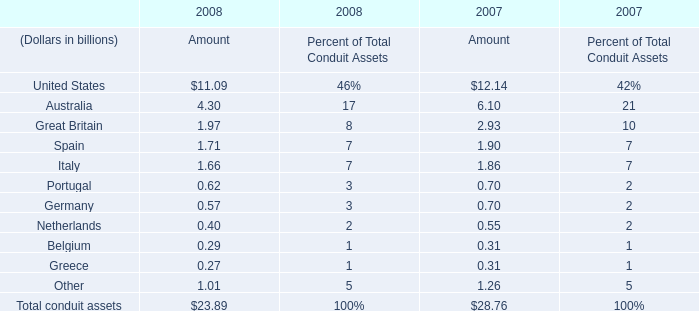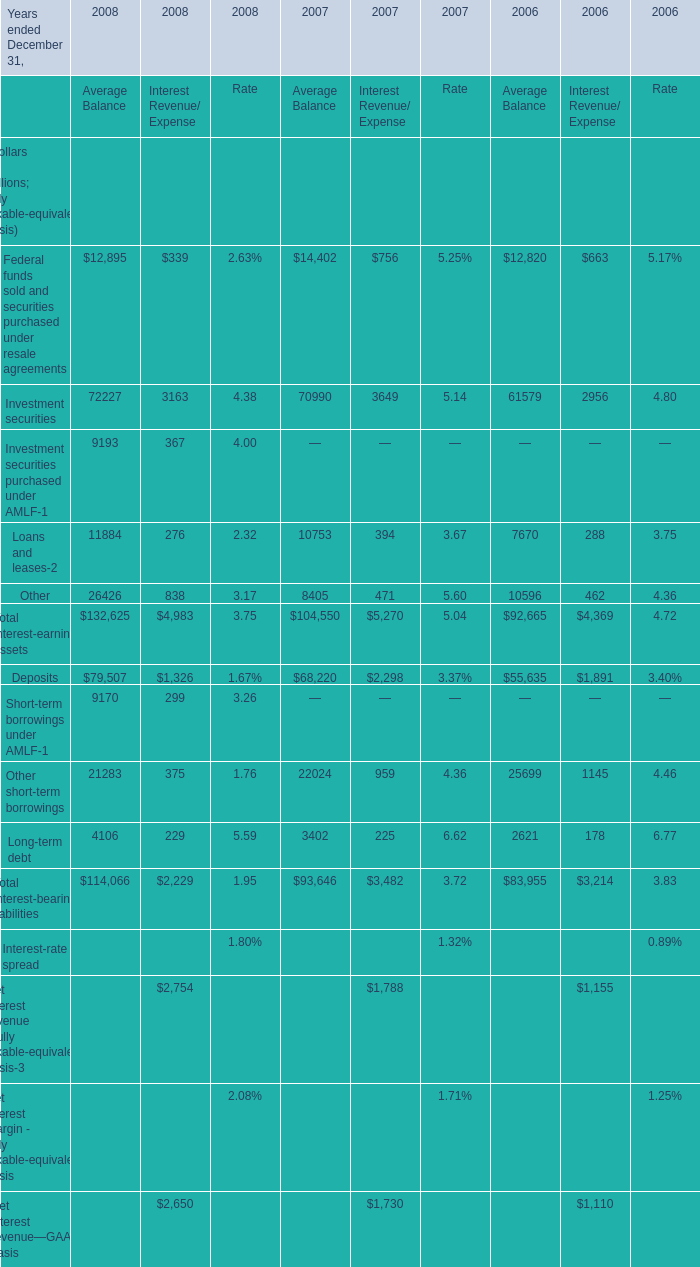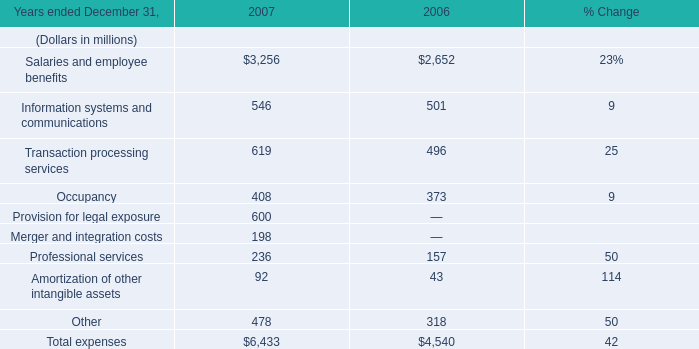As As the chart 1 shows, for what Year(ended December 31,what Year) is the Rate for the Net interest margin - fully taxable-equivalent basis greater than 0.0208 ? 
Answer: 2008. 